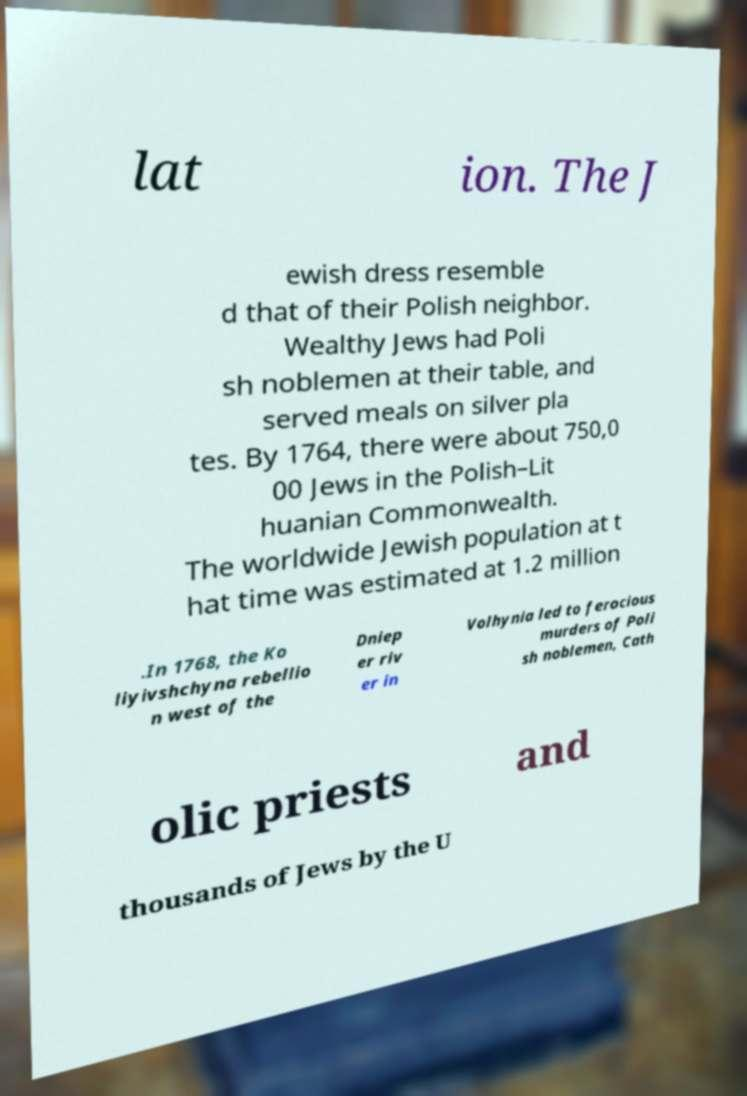There's text embedded in this image that I need extracted. Can you transcribe it verbatim? lat ion. The J ewish dress resemble d that of their Polish neighbor. Wealthy Jews had Poli sh noblemen at their table, and served meals on silver pla tes. By 1764, there were about 750,0 00 Jews in the Polish–Lit huanian Commonwealth. The worldwide Jewish population at t hat time was estimated at 1.2 million .In 1768, the Ko liyivshchyna rebellio n west of the Dniep er riv er in Volhynia led to ferocious murders of Poli sh noblemen, Cath olic priests and thousands of Jews by the U 